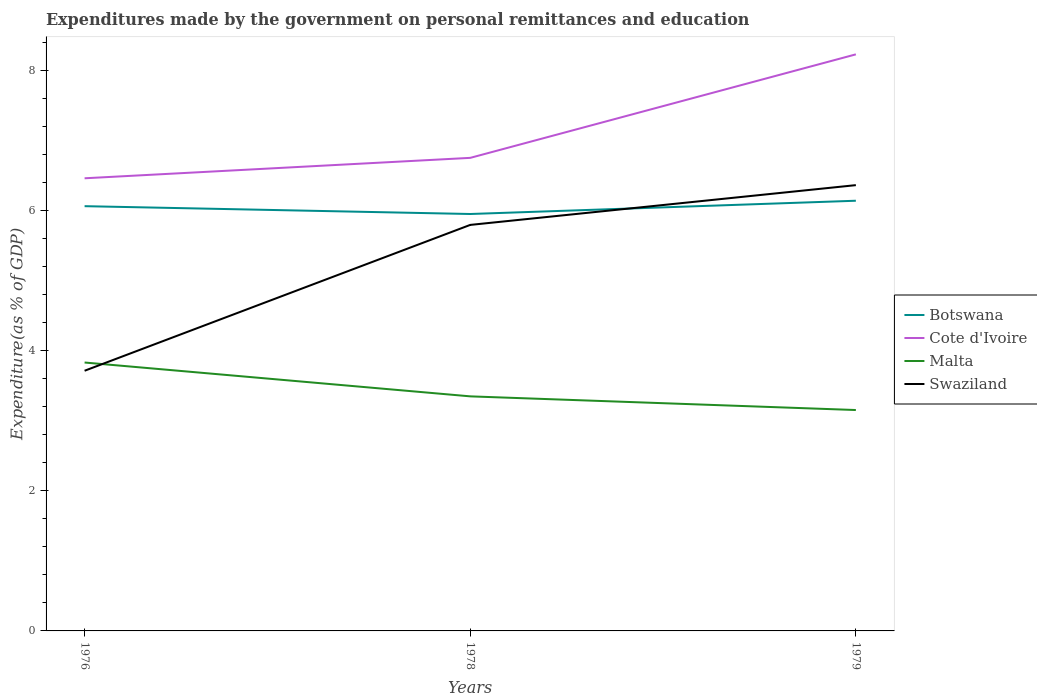Is the number of lines equal to the number of legend labels?
Make the answer very short. Yes. Across all years, what is the maximum expenditures made by the government on personal remittances and education in Swaziland?
Provide a succinct answer. 3.71. In which year was the expenditures made by the government on personal remittances and education in Botswana maximum?
Ensure brevity in your answer.  1978. What is the total expenditures made by the government on personal remittances and education in Cote d'Ivoire in the graph?
Your answer should be compact. -1.77. What is the difference between the highest and the second highest expenditures made by the government on personal remittances and education in Botswana?
Provide a short and direct response. 0.19. What is the difference between the highest and the lowest expenditures made by the government on personal remittances and education in Botswana?
Provide a short and direct response. 2. Are the values on the major ticks of Y-axis written in scientific E-notation?
Your answer should be compact. No. Does the graph contain any zero values?
Offer a terse response. No. Where does the legend appear in the graph?
Provide a succinct answer. Center right. How many legend labels are there?
Your response must be concise. 4. How are the legend labels stacked?
Offer a terse response. Vertical. What is the title of the graph?
Offer a terse response. Expenditures made by the government on personal remittances and education. Does "Haiti" appear as one of the legend labels in the graph?
Your answer should be compact. No. What is the label or title of the Y-axis?
Make the answer very short. Expenditure(as % of GDP). What is the Expenditure(as % of GDP) of Botswana in 1976?
Offer a terse response. 6.06. What is the Expenditure(as % of GDP) in Cote d'Ivoire in 1976?
Make the answer very short. 6.46. What is the Expenditure(as % of GDP) of Malta in 1976?
Your response must be concise. 3.83. What is the Expenditure(as % of GDP) in Swaziland in 1976?
Your response must be concise. 3.71. What is the Expenditure(as % of GDP) in Botswana in 1978?
Offer a terse response. 5.95. What is the Expenditure(as % of GDP) of Cote d'Ivoire in 1978?
Your answer should be compact. 6.75. What is the Expenditure(as % of GDP) of Malta in 1978?
Ensure brevity in your answer.  3.35. What is the Expenditure(as % of GDP) of Swaziland in 1978?
Ensure brevity in your answer.  5.8. What is the Expenditure(as % of GDP) in Botswana in 1979?
Provide a succinct answer. 6.14. What is the Expenditure(as % of GDP) of Cote d'Ivoire in 1979?
Provide a succinct answer. 8.23. What is the Expenditure(as % of GDP) in Malta in 1979?
Offer a very short reply. 3.15. What is the Expenditure(as % of GDP) of Swaziland in 1979?
Your response must be concise. 6.36. Across all years, what is the maximum Expenditure(as % of GDP) of Botswana?
Give a very brief answer. 6.14. Across all years, what is the maximum Expenditure(as % of GDP) of Cote d'Ivoire?
Ensure brevity in your answer.  8.23. Across all years, what is the maximum Expenditure(as % of GDP) of Malta?
Your answer should be compact. 3.83. Across all years, what is the maximum Expenditure(as % of GDP) in Swaziland?
Provide a short and direct response. 6.36. Across all years, what is the minimum Expenditure(as % of GDP) in Botswana?
Your answer should be compact. 5.95. Across all years, what is the minimum Expenditure(as % of GDP) of Cote d'Ivoire?
Provide a short and direct response. 6.46. Across all years, what is the minimum Expenditure(as % of GDP) in Malta?
Your answer should be compact. 3.15. Across all years, what is the minimum Expenditure(as % of GDP) in Swaziland?
Your answer should be very brief. 3.71. What is the total Expenditure(as % of GDP) in Botswana in the graph?
Your answer should be very brief. 18.16. What is the total Expenditure(as % of GDP) of Cote d'Ivoire in the graph?
Provide a succinct answer. 21.45. What is the total Expenditure(as % of GDP) of Malta in the graph?
Give a very brief answer. 10.33. What is the total Expenditure(as % of GDP) in Swaziland in the graph?
Your answer should be very brief. 15.88. What is the difference between the Expenditure(as % of GDP) of Botswana in 1976 and that in 1978?
Your response must be concise. 0.11. What is the difference between the Expenditure(as % of GDP) in Cote d'Ivoire in 1976 and that in 1978?
Offer a very short reply. -0.29. What is the difference between the Expenditure(as % of GDP) of Malta in 1976 and that in 1978?
Give a very brief answer. 0.48. What is the difference between the Expenditure(as % of GDP) in Swaziland in 1976 and that in 1978?
Provide a short and direct response. -2.08. What is the difference between the Expenditure(as % of GDP) of Botswana in 1976 and that in 1979?
Give a very brief answer. -0.08. What is the difference between the Expenditure(as % of GDP) of Cote d'Ivoire in 1976 and that in 1979?
Make the answer very short. -1.77. What is the difference between the Expenditure(as % of GDP) in Malta in 1976 and that in 1979?
Give a very brief answer. 0.68. What is the difference between the Expenditure(as % of GDP) in Swaziland in 1976 and that in 1979?
Ensure brevity in your answer.  -2.65. What is the difference between the Expenditure(as % of GDP) in Botswana in 1978 and that in 1979?
Your response must be concise. -0.19. What is the difference between the Expenditure(as % of GDP) of Cote d'Ivoire in 1978 and that in 1979?
Offer a terse response. -1.48. What is the difference between the Expenditure(as % of GDP) in Malta in 1978 and that in 1979?
Give a very brief answer. 0.2. What is the difference between the Expenditure(as % of GDP) of Swaziland in 1978 and that in 1979?
Ensure brevity in your answer.  -0.57. What is the difference between the Expenditure(as % of GDP) in Botswana in 1976 and the Expenditure(as % of GDP) in Cote d'Ivoire in 1978?
Make the answer very short. -0.69. What is the difference between the Expenditure(as % of GDP) of Botswana in 1976 and the Expenditure(as % of GDP) of Malta in 1978?
Your answer should be very brief. 2.72. What is the difference between the Expenditure(as % of GDP) in Botswana in 1976 and the Expenditure(as % of GDP) in Swaziland in 1978?
Keep it short and to the point. 0.27. What is the difference between the Expenditure(as % of GDP) in Cote d'Ivoire in 1976 and the Expenditure(as % of GDP) in Malta in 1978?
Your answer should be compact. 3.11. What is the difference between the Expenditure(as % of GDP) in Cote d'Ivoire in 1976 and the Expenditure(as % of GDP) in Swaziland in 1978?
Offer a very short reply. 0.67. What is the difference between the Expenditure(as % of GDP) in Malta in 1976 and the Expenditure(as % of GDP) in Swaziland in 1978?
Provide a succinct answer. -1.96. What is the difference between the Expenditure(as % of GDP) of Botswana in 1976 and the Expenditure(as % of GDP) of Cote d'Ivoire in 1979?
Your response must be concise. -2.17. What is the difference between the Expenditure(as % of GDP) in Botswana in 1976 and the Expenditure(as % of GDP) in Malta in 1979?
Your answer should be compact. 2.91. What is the difference between the Expenditure(as % of GDP) of Botswana in 1976 and the Expenditure(as % of GDP) of Swaziland in 1979?
Keep it short and to the point. -0.3. What is the difference between the Expenditure(as % of GDP) of Cote d'Ivoire in 1976 and the Expenditure(as % of GDP) of Malta in 1979?
Offer a terse response. 3.31. What is the difference between the Expenditure(as % of GDP) of Cote d'Ivoire in 1976 and the Expenditure(as % of GDP) of Swaziland in 1979?
Your response must be concise. 0.1. What is the difference between the Expenditure(as % of GDP) in Malta in 1976 and the Expenditure(as % of GDP) in Swaziland in 1979?
Your answer should be compact. -2.53. What is the difference between the Expenditure(as % of GDP) in Botswana in 1978 and the Expenditure(as % of GDP) in Cote d'Ivoire in 1979?
Offer a terse response. -2.28. What is the difference between the Expenditure(as % of GDP) in Botswana in 1978 and the Expenditure(as % of GDP) in Malta in 1979?
Offer a terse response. 2.8. What is the difference between the Expenditure(as % of GDP) in Botswana in 1978 and the Expenditure(as % of GDP) in Swaziland in 1979?
Your answer should be very brief. -0.41. What is the difference between the Expenditure(as % of GDP) of Cote d'Ivoire in 1978 and the Expenditure(as % of GDP) of Malta in 1979?
Provide a succinct answer. 3.6. What is the difference between the Expenditure(as % of GDP) in Cote d'Ivoire in 1978 and the Expenditure(as % of GDP) in Swaziland in 1979?
Your answer should be compact. 0.39. What is the difference between the Expenditure(as % of GDP) in Malta in 1978 and the Expenditure(as % of GDP) in Swaziland in 1979?
Provide a short and direct response. -3.02. What is the average Expenditure(as % of GDP) in Botswana per year?
Provide a succinct answer. 6.05. What is the average Expenditure(as % of GDP) of Cote d'Ivoire per year?
Your response must be concise. 7.15. What is the average Expenditure(as % of GDP) of Malta per year?
Ensure brevity in your answer.  3.44. What is the average Expenditure(as % of GDP) in Swaziland per year?
Provide a short and direct response. 5.29. In the year 1976, what is the difference between the Expenditure(as % of GDP) in Botswana and Expenditure(as % of GDP) in Cote d'Ivoire?
Ensure brevity in your answer.  -0.4. In the year 1976, what is the difference between the Expenditure(as % of GDP) in Botswana and Expenditure(as % of GDP) in Malta?
Your answer should be compact. 2.23. In the year 1976, what is the difference between the Expenditure(as % of GDP) of Botswana and Expenditure(as % of GDP) of Swaziland?
Offer a terse response. 2.35. In the year 1976, what is the difference between the Expenditure(as % of GDP) of Cote d'Ivoire and Expenditure(as % of GDP) of Malta?
Your answer should be compact. 2.63. In the year 1976, what is the difference between the Expenditure(as % of GDP) of Cote d'Ivoire and Expenditure(as % of GDP) of Swaziland?
Provide a succinct answer. 2.75. In the year 1976, what is the difference between the Expenditure(as % of GDP) of Malta and Expenditure(as % of GDP) of Swaziland?
Your answer should be very brief. 0.12. In the year 1978, what is the difference between the Expenditure(as % of GDP) in Botswana and Expenditure(as % of GDP) in Cote d'Ivoire?
Make the answer very short. -0.8. In the year 1978, what is the difference between the Expenditure(as % of GDP) in Botswana and Expenditure(as % of GDP) in Malta?
Provide a short and direct response. 2.6. In the year 1978, what is the difference between the Expenditure(as % of GDP) of Botswana and Expenditure(as % of GDP) of Swaziland?
Your answer should be compact. 0.16. In the year 1978, what is the difference between the Expenditure(as % of GDP) in Cote d'Ivoire and Expenditure(as % of GDP) in Malta?
Provide a succinct answer. 3.4. In the year 1978, what is the difference between the Expenditure(as % of GDP) in Cote d'Ivoire and Expenditure(as % of GDP) in Swaziland?
Offer a very short reply. 0.96. In the year 1978, what is the difference between the Expenditure(as % of GDP) of Malta and Expenditure(as % of GDP) of Swaziland?
Offer a terse response. -2.45. In the year 1979, what is the difference between the Expenditure(as % of GDP) in Botswana and Expenditure(as % of GDP) in Cote d'Ivoire?
Make the answer very short. -2.09. In the year 1979, what is the difference between the Expenditure(as % of GDP) in Botswana and Expenditure(as % of GDP) in Malta?
Your answer should be very brief. 2.99. In the year 1979, what is the difference between the Expenditure(as % of GDP) in Botswana and Expenditure(as % of GDP) in Swaziland?
Offer a very short reply. -0.22. In the year 1979, what is the difference between the Expenditure(as % of GDP) in Cote d'Ivoire and Expenditure(as % of GDP) in Malta?
Make the answer very short. 5.08. In the year 1979, what is the difference between the Expenditure(as % of GDP) of Cote d'Ivoire and Expenditure(as % of GDP) of Swaziland?
Ensure brevity in your answer.  1.87. In the year 1979, what is the difference between the Expenditure(as % of GDP) of Malta and Expenditure(as % of GDP) of Swaziland?
Offer a very short reply. -3.21. What is the ratio of the Expenditure(as % of GDP) of Botswana in 1976 to that in 1978?
Keep it short and to the point. 1.02. What is the ratio of the Expenditure(as % of GDP) in Cote d'Ivoire in 1976 to that in 1978?
Offer a terse response. 0.96. What is the ratio of the Expenditure(as % of GDP) of Malta in 1976 to that in 1978?
Offer a terse response. 1.14. What is the ratio of the Expenditure(as % of GDP) of Swaziland in 1976 to that in 1978?
Ensure brevity in your answer.  0.64. What is the ratio of the Expenditure(as % of GDP) of Botswana in 1976 to that in 1979?
Provide a succinct answer. 0.99. What is the ratio of the Expenditure(as % of GDP) in Cote d'Ivoire in 1976 to that in 1979?
Provide a succinct answer. 0.79. What is the ratio of the Expenditure(as % of GDP) of Malta in 1976 to that in 1979?
Your answer should be very brief. 1.22. What is the ratio of the Expenditure(as % of GDP) of Swaziland in 1976 to that in 1979?
Your response must be concise. 0.58. What is the ratio of the Expenditure(as % of GDP) of Botswana in 1978 to that in 1979?
Provide a succinct answer. 0.97. What is the ratio of the Expenditure(as % of GDP) of Cote d'Ivoire in 1978 to that in 1979?
Your response must be concise. 0.82. What is the ratio of the Expenditure(as % of GDP) of Malta in 1978 to that in 1979?
Your answer should be compact. 1.06. What is the ratio of the Expenditure(as % of GDP) in Swaziland in 1978 to that in 1979?
Your answer should be compact. 0.91. What is the difference between the highest and the second highest Expenditure(as % of GDP) in Botswana?
Your answer should be compact. 0.08. What is the difference between the highest and the second highest Expenditure(as % of GDP) of Cote d'Ivoire?
Give a very brief answer. 1.48. What is the difference between the highest and the second highest Expenditure(as % of GDP) of Malta?
Make the answer very short. 0.48. What is the difference between the highest and the second highest Expenditure(as % of GDP) in Swaziland?
Offer a very short reply. 0.57. What is the difference between the highest and the lowest Expenditure(as % of GDP) of Botswana?
Make the answer very short. 0.19. What is the difference between the highest and the lowest Expenditure(as % of GDP) of Cote d'Ivoire?
Your response must be concise. 1.77. What is the difference between the highest and the lowest Expenditure(as % of GDP) in Malta?
Keep it short and to the point. 0.68. What is the difference between the highest and the lowest Expenditure(as % of GDP) in Swaziland?
Ensure brevity in your answer.  2.65. 